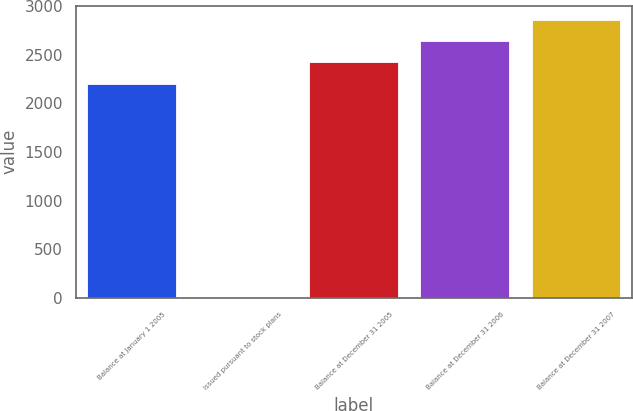Convert chart to OTSL. <chart><loc_0><loc_0><loc_500><loc_500><bar_chart><fcel>Balance at January 1 2005<fcel>Issued pursuant to stock plans<fcel>Balance at December 31 2005<fcel>Balance at December 31 2006<fcel>Balance at December 31 2007<nl><fcel>2202<fcel>3<fcel>2422.2<fcel>2642.4<fcel>2862.6<nl></chart> 